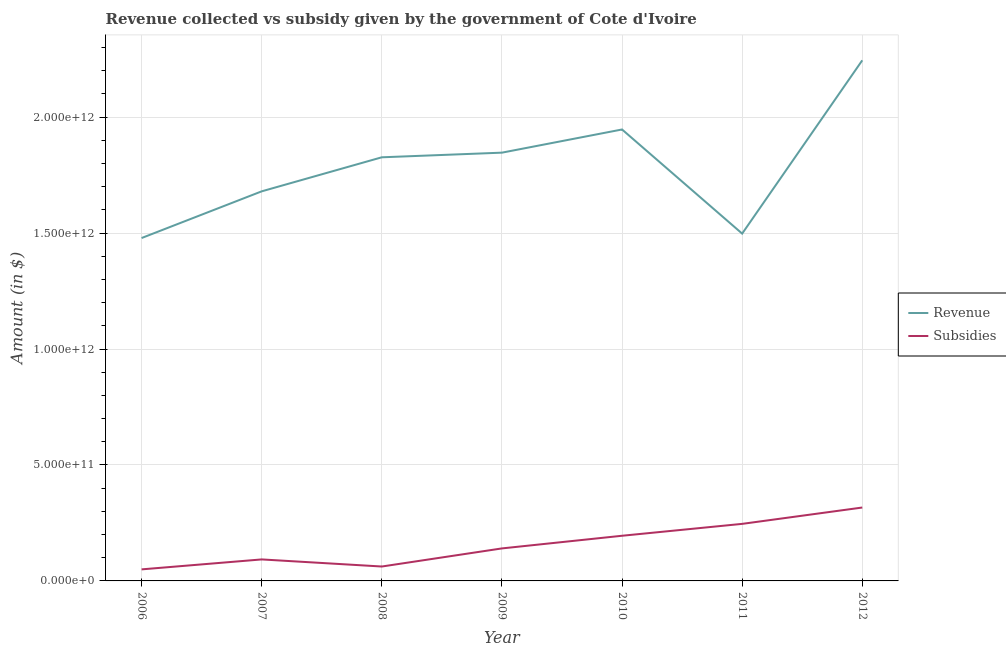How many different coloured lines are there?
Offer a very short reply. 2. Does the line corresponding to amount of revenue collected intersect with the line corresponding to amount of subsidies given?
Your answer should be compact. No. Is the number of lines equal to the number of legend labels?
Your answer should be compact. Yes. What is the amount of subsidies given in 2010?
Keep it short and to the point. 1.95e+11. Across all years, what is the maximum amount of subsidies given?
Provide a succinct answer. 3.17e+11. Across all years, what is the minimum amount of revenue collected?
Give a very brief answer. 1.48e+12. What is the total amount of subsidies given in the graph?
Offer a very short reply. 1.10e+12. What is the difference between the amount of subsidies given in 2006 and that in 2009?
Your response must be concise. -9.04e+1. What is the difference between the amount of revenue collected in 2011 and the amount of subsidies given in 2009?
Provide a short and direct response. 1.36e+12. What is the average amount of revenue collected per year?
Keep it short and to the point. 1.79e+12. In the year 2007, what is the difference between the amount of subsidies given and amount of revenue collected?
Make the answer very short. -1.59e+12. In how many years, is the amount of revenue collected greater than 2000000000000 $?
Your answer should be compact. 1. What is the ratio of the amount of revenue collected in 2007 to that in 2009?
Give a very brief answer. 0.91. Is the difference between the amount of subsidies given in 2006 and 2010 greater than the difference between the amount of revenue collected in 2006 and 2010?
Give a very brief answer. Yes. What is the difference between the highest and the second highest amount of subsidies given?
Your answer should be compact. 7.05e+1. What is the difference between the highest and the lowest amount of subsidies given?
Your answer should be very brief. 2.67e+11. In how many years, is the amount of revenue collected greater than the average amount of revenue collected taken over all years?
Provide a short and direct response. 4. Is the sum of the amount of subsidies given in 2006 and 2008 greater than the maximum amount of revenue collected across all years?
Provide a short and direct response. No. Does the amount of revenue collected monotonically increase over the years?
Provide a short and direct response. No. Is the amount of revenue collected strictly less than the amount of subsidies given over the years?
Your answer should be very brief. No. How many lines are there?
Ensure brevity in your answer.  2. What is the difference between two consecutive major ticks on the Y-axis?
Ensure brevity in your answer.  5.00e+11. Are the values on the major ticks of Y-axis written in scientific E-notation?
Keep it short and to the point. Yes. What is the title of the graph?
Provide a succinct answer. Revenue collected vs subsidy given by the government of Cote d'Ivoire. What is the label or title of the Y-axis?
Your answer should be compact. Amount (in $). What is the Amount (in $) of Revenue in 2006?
Your response must be concise. 1.48e+12. What is the Amount (in $) of Subsidies in 2006?
Your answer should be compact. 4.98e+1. What is the Amount (in $) of Revenue in 2007?
Your answer should be compact. 1.68e+12. What is the Amount (in $) of Subsidies in 2007?
Ensure brevity in your answer.  9.27e+1. What is the Amount (in $) of Revenue in 2008?
Provide a short and direct response. 1.83e+12. What is the Amount (in $) in Subsidies in 2008?
Provide a short and direct response. 6.21e+1. What is the Amount (in $) of Revenue in 2009?
Your answer should be compact. 1.85e+12. What is the Amount (in $) of Subsidies in 2009?
Provide a succinct answer. 1.40e+11. What is the Amount (in $) of Revenue in 2010?
Offer a very short reply. 1.95e+12. What is the Amount (in $) of Subsidies in 2010?
Offer a very short reply. 1.95e+11. What is the Amount (in $) in Revenue in 2011?
Your answer should be compact. 1.50e+12. What is the Amount (in $) in Subsidies in 2011?
Offer a terse response. 2.46e+11. What is the Amount (in $) of Revenue in 2012?
Your answer should be compact. 2.24e+12. What is the Amount (in $) of Subsidies in 2012?
Give a very brief answer. 3.17e+11. Across all years, what is the maximum Amount (in $) in Revenue?
Give a very brief answer. 2.24e+12. Across all years, what is the maximum Amount (in $) of Subsidies?
Keep it short and to the point. 3.17e+11. Across all years, what is the minimum Amount (in $) in Revenue?
Make the answer very short. 1.48e+12. Across all years, what is the minimum Amount (in $) of Subsidies?
Keep it short and to the point. 4.98e+1. What is the total Amount (in $) in Revenue in the graph?
Give a very brief answer. 1.25e+13. What is the total Amount (in $) in Subsidies in the graph?
Provide a short and direct response. 1.10e+12. What is the difference between the Amount (in $) of Revenue in 2006 and that in 2007?
Your response must be concise. -2.01e+11. What is the difference between the Amount (in $) of Subsidies in 2006 and that in 2007?
Provide a succinct answer. -4.29e+1. What is the difference between the Amount (in $) in Revenue in 2006 and that in 2008?
Give a very brief answer. -3.48e+11. What is the difference between the Amount (in $) in Subsidies in 2006 and that in 2008?
Your response must be concise. -1.23e+1. What is the difference between the Amount (in $) in Revenue in 2006 and that in 2009?
Your response must be concise. -3.68e+11. What is the difference between the Amount (in $) in Subsidies in 2006 and that in 2009?
Provide a succinct answer. -9.04e+1. What is the difference between the Amount (in $) of Revenue in 2006 and that in 2010?
Ensure brevity in your answer.  -4.68e+11. What is the difference between the Amount (in $) of Subsidies in 2006 and that in 2010?
Give a very brief answer. -1.45e+11. What is the difference between the Amount (in $) of Revenue in 2006 and that in 2011?
Provide a short and direct response. -1.91e+1. What is the difference between the Amount (in $) of Subsidies in 2006 and that in 2011?
Your answer should be very brief. -1.96e+11. What is the difference between the Amount (in $) of Revenue in 2006 and that in 2012?
Your answer should be compact. -7.66e+11. What is the difference between the Amount (in $) in Subsidies in 2006 and that in 2012?
Keep it short and to the point. -2.67e+11. What is the difference between the Amount (in $) of Revenue in 2007 and that in 2008?
Provide a succinct answer. -1.47e+11. What is the difference between the Amount (in $) in Subsidies in 2007 and that in 2008?
Your answer should be compact. 3.06e+1. What is the difference between the Amount (in $) in Revenue in 2007 and that in 2009?
Your answer should be compact. -1.67e+11. What is the difference between the Amount (in $) in Subsidies in 2007 and that in 2009?
Your answer should be very brief. -4.75e+1. What is the difference between the Amount (in $) in Revenue in 2007 and that in 2010?
Ensure brevity in your answer.  -2.67e+11. What is the difference between the Amount (in $) in Subsidies in 2007 and that in 2010?
Offer a terse response. -1.02e+11. What is the difference between the Amount (in $) in Revenue in 2007 and that in 2011?
Offer a terse response. 1.82e+11. What is the difference between the Amount (in $) in Subsidies in 2007 and that in 2011?
Your answer should be compact. -1.53e+11. What is the difference between the Amount (in $) in Revenue in 2007 and that in 2012?
Your response must be concise. -5.65e+11. What is the difference between the Amount (in $) of Subsidies in 2007 and that in 2012?
Offer a terse response. -2.24e+11. What is the difference between the Amount (in $) of Revenue in 2008 and that in 2009?
Keep it short and to the point. -2.00e+1. What is the difference between the Amount (in $) in Subsidies in 2008 and that in 2009?
Keep it short and to the point. -7.81e+1. What is the difference between the Amount (in $) of Revenue in 2008 and that in 2010?
Give a very brief answer. -1.20e+11. What is the difference between the Amount (in $) in Subsidies in 2008 and that in 2010?
Offer a very short reply. -1.33e+11. What is the difference between the Amount (in $) in Revenue in 2008 and that in 2011?
Offer a very short reply. 3.29e+11. What is the difference between the Amount (in $) in Subsidies in 2008 and that in 2011?
Provide a succinct answer. -1.84e+11. What is the difference between the Amount (in $) in Revenue in 2008 and that in 2012?
Give a very brief answer. -4.18e+11. What is the difference between the Amount (in $) of Subsidies in 2008 and that in 2012?
Your response must be concise. -2.54e+11. What is the difference between the Amount (in $) in Revenue in 2009 and that in 2010?
Give a very brief answer. -9.99e+1. What is the difference between the Amount (in $) of Subsidies in 2009 and that in 2010?
Offer a very short reply. -5.46e+1. What is the difference between the Amount (in $) of Revenue in 2009 and that in 2011?
Make the answer very short. 3.49e+11. What is the difference between the Amount (in $) in Subsidies in 2009 and that in 2011?
Keep it short and to the point. -1.06e+11. What is the difference between the Amount (in $) of Revenue in 2009 and that in 2012?
Your answer should be compact. -3.98e+11. What is the difference between the Amount (in $) in Subsidies in 2009 and that in 2012?
Give a very brief answer. -1.76e+11. What is the difference between the Amount (in $) of Revenue in 2010 and that in 2011?
Offer a terse response. 4.49e+11. What is the difference between the Amount (in $) in Subsidies in 2010 and that in 2011?
Keep it short and to the point. -5.13e+1. What is the difference between the Amount (in $) of Revenue in 2010 and that in 2012?
Your answer should be compact. -2.98e+11. What is the difference between the Amount (in $) in Subsidies in 2010 and that in 2012?
Your answer should be compact. -1.22e+11. What is the difference between the Amount (in $) in Revenue in 2011 and that in 2012?
Ensure brevity in your answer.  -7.47e+11. What is the difference between the Amount (in $) of Subsidies in 2011 and that in 2012?
Your answer should be compact. -7.05e+1. What is the difference between the Amount (in $) in Revenue in 2006 and the Amount (in $) in Subsidies in 2007?
Make the answer very short. 1.39e+12. What is the difference between the Amount (in $) in Revenue in 2006 and the Amount (in $) in Subsidies in 2008?
Your answer should be very brief. 1.42e+12. What is the difference between the Amount (in $) in Revenue in 2006 and the Amount (in $) in Subsidies in 2009?
Your answer should be very brief. 1.34e+12. What is the difference between the Amount (in $) of Revenue in 2006 and the Amount (in $) of Subsidies in 2010?
Give a very brief answer. 1.28e+12. What is the difference between the Amount (in $) of Revenue in 2006 and the Amount (in $) of Subsidies in 2011?
Keep it short and to the point. 1.23e+12. What is the difference between the Amount (in $) of Revenue in 2006 and the Amount (in $) of Subsidies in 2012?
Your answer should be compact. 1.16e+12. What is the difference between the Amount (in $) in Revenue in 2007 and the Amount (in $) in Subsidies in 2008?
Provide a succinct answer. 1.62e+12. What is the difference between the Amount (in $) of Revenue in 2007 and the Amount (in $) of Subsidies in 2009?
Offer a very short reply. 1.54e+12. What is the difference between the Amount (in $) in Revenue in 2007 and the Amount (in $) in Subsidies in 2010?
Your response must be concise. 1.49e+12. What is the difference between the Amount (in $) in Revenue in 2007 and the Amount (in $) in Subsidies in 2011?
Your answer should be compact. 1.43e+12. What is the difference between the Amount (in $) of Revenue in 2007 and the Amount (in $) of Subsidies in 2012?
Ensure brevity in your answer.  1.36e+12. What is the difference between the Amount (in $) in Revenue in 2008 and the Amount (in $) in Subsidies in 2009?
Make the answer very short. 1.69e+12. What is the difference between the Amount (in $) of Revenue in 2008 and the Amount (in $) of Subsidies in 2010?
Your answer should be very brief. 1.63e+12. What is the difference between the Amount (in $) of Revenue in 2008 and the Amount (in $) of Subsidies in 2011?
Provide a short and direct response. 1.58e+12. What is the difference between the Amount (in $) of Revenue in 2008 and the Amount (in $) of Subsidies in 2012?
Provide a succinct answer. 1.51e+12. What is the difference between the Amount (in $) of Revenue in 2009 and the Amount (in $) of Subsidies in 2010?
Provide a succinct answer. 1.65e+12. What is the difference between the Amount (in $) in Revenue in 2009 and the Amount (in $) in Subsidies in 2011?
Make the answer very short. 1.60e+12. What is the difference between the Amount (in $) of Revenue in 2009 and the Amount (in $) of Subsidies in 2012?
Your answer should be very brief. 1.53e+12. What is the difference between the Amount (in $) of Revenue in 2010 and the Amount (in $) of Subsidies in 2011?
Ensure brevity in your answer.  1.70e+12. What is the difference between the Amount (in $) in Revenue in 2010 and the Amount (in $) in Subsidies in 2012?
Ensure brevity in your answer.  1.63e+12. What is the difference between the Amount (in $) in Revenue in 2011 and the Amount (in $) in Subsidies in 2012?
Offer a terse response. 1.18e+12. What is the average Amount (in $) in Revenue per year?
Provide a short and direct response. 1.79e+12. What is the average Amount (in $) of Subsidies per year?
Ensure brevity in your answer.  1.57e+11. In the year 2006, what is the difference between the Amount (in $) of Revenue and Amount (in $) of Subsidies?
Make the answer very short. 1.43e+12. In the year 2007, what is the difference between the Amount (in $) of Revenue and Amount (in $) of Subsidies?
Your answer should be very brief. 1.59e+12. In the year 2008, what is the difference between the Amount (in $) of Revenue and Amount (in $) of Subsidies?
Keep it short and to the point. 1.76e+12. In the year 2009, what is the difference between the Amount (in $) of Revenue and Amount (in $) of Subsidies?
Make the answer very short. 1.71e+12. In the year 2010, what is the difference between the Amount (in $) in Revenue and Amount (in $) in Subsidies?
Ensure brevity in your answer.  1.75e+12. In the year 2011, what is the difference between the Amount (in $) of Revenue and Amount (in $) of Subsidies?
Give a very brief answer. 1.25e+12. In the year 2012, what is the difference between the Amount (in $) in Revenue and Amount (in $) in Subsidies?
Your response must be concise. 1.93e+12. What is the ratio of the Amount (in $) of Revenue in 2006 to that in 2007?
Your answer should be compact. 0.88. What is the ratio of the Amount (in $) in Subsidies in 2006 to that in 2007?
Your answer should be compact. 0.54. What is the ratio of the Amount (in $) in Revenue in 2006 to that in 2008?
Make the answer very short. 0.81. What is the ratio of the Amount (in $) of Subsidies in 2006 to that in 2008?
Provide a succinct answer. 0.8. What is the ratio of the Amount (in $) of Revenue in 2006 to that in 2009?
Your answer should be very brief. 0.8. What is the ratio of the Amount (in $) of Subsidies in 2006 to that in 2009?
Provide a succinct answer. 0.36. What is the ratio of the Amount (in $) in Revenue in 2006 to that in 2010?
Your answer should be compact. 0.76. What is the ratio of the Amount (in $) of Subsidies in 2006 to that in 2010?
Ensure brevity in your answer.  0.26. What is the ratio of the Amount (in $) of Revenue in 2006 to that in 2011?
Ensure brevity in your answer.  0.99. What is the ratio of the Amount (in $) of Subsidies in 2006 to that in 2011?
Keep it short and to the point. 0.2. What is the ratio of the Amount (in $) of Revenue in 2006 to that in 2012?
Provide a short and direct response. 0.66. What is the ratio of the Amount (in $) in Subsidies in 2006 to that in 2012?
Your answer should be compact. 0.16. What is the ratio of the Amount (in $) in Revenue in 2007 to that in 2008?
Your answer should be compact. 0.92. What is the ratio of the Amount (in $) in Subsidies in 2007 to that in 2008?
Your answer should be very brief. 1.49. What is the ratio of the Amount (in $) in Revenue in 2007 to that in 2009?
Your response must be concise. 0.91. What is the ratio of the Amount (in $) of Subsidies in 2007 to that in 2009?
Offer a terse response. 0.66. What is the ratio of the Amount (in $) in Revenue in 2007 to that in 2010?
Ensure brevity in your answer.  0.86. What is the ratio of the Amount (in $) of Subsidies in 2007 to that in 2010?
Offer a terse response. 0.48. What is the ratio of the Amount (in $) of Revenue in 2007 to that in 2011?
Give a very brief answer. 1.12. What is the ratio of the Amount (in $) in Subsidies in 2007 to that in 2011?
Keep it short and to the point. 0.38. What is the ratio of the Amount (in $) of Revenue in 2007 to that in 2012?
Your answer should be compact. 0.75. What is the ratio of the Amount (in $) of Subsidies in 2007 to that in 2012?
Keep it short and to the point. 0.29. What is the ratio of the Amount (in $) in Revenue in 2008 to that in 2009?
Make the answer very short. 0.99. What is the ratio of the Amount (in $) in Subsidies in 2008 to that in 2009?
Keep it short and to the point. 0.44. What is the ratio of the Amount (in $) in Revenue in 2008 to that in 2010?
Give a very brief answer. 0.94. What is the ratio of the Amount (in $) of Subsidies in 2008 to that in 2010?
Offer a terse response. 0.32. What is the ratio of the Amount (in $) of Revenue in 2008 to that in 2011?
Make the answer very short. 1.22. What is the ratio of the Amount (in $) in Subsidies in 2008 to that in 2011?
Your answer should be compact. 0.25. What is the ratio of the Amount (in $) in Revenue in 2008 to that in 2012?
Make the answer very short. 0.81. What is the ratio of the Amount (in $) in Subsidies in 2008 to that in 2012?
Provide a succinct answer. 0.2. What is the ratio of the Amount (in $) in Revenue in 2009 to that in 2010?
Make the answer very short. 0.95. What is the ratio of the Amount (in $) in Subsidies in 2009 to that in 2010?
Offer a very short reply. 0.72. What is the ratio of the Amount (in $) of Revenue in 2009 to that in 2011?
Ensure brevity in your answer.  1.23. What is the ratio of the Amount (in $) of Subsidies in 2009 to that in 2011?
Give a very brief answer. 0.57. What is the ratio of the Amount (in $) of Revenue in 2009 to that in 2012?
Your answer should be very brief. 0.82. What is the ratio of the Amount (in $) in Subsidies in 2009 to that in 2012?
Give a very brief answer. 0.44. What is the ratio of the Amount (in $) in Revenue in 2010 to that in 2011?
Provide a succinct answer. 1.3. What is the ratio of the Amount (in $) in Subsidies in 2010 to that in 2011?
Provide a succinct answer. 0.79. What is the ratio of the Amount (in $) of Revenue in 2010 to that in 2012?
Your response must be concise. 0.87. What is the ratio of the Amount (in $) in Subsidies in 2010 to that in 2012?
Provide a succinct answer. 0.62. What is the ratio of the Amount (in $) of Revenue in 2011 to that in 2012?
Your answer should be very brief. 0.67. What is the ratio of the Amount (in $) of Subsidies in 2011 to that in 2012?
Keep it short and to the point. 0.78. What is the difference between the highest and the second highest Amount (in $) of Revenue?
Provide a succinct answer. 2.98e+11. What is the difference between the highest and the second highest Amount (in $) of Subsidies?
Keep it short and to the point. 7.05e+1. What is the difference between the highest and the lowest Amount (in $) of Revenue?
Your answer should be compact. 7.66e+11. What is the difference between the highest and the lowest Amount (in $) in Subsidies?
Make the answer very short. 2.67e+11. 